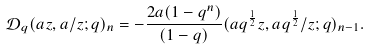Convert formula to latex. <formula><loc_0><loc_0><loc_500><loc_500>\mathcal { D } _ { q } ( a z , a / z ; q ) _ { n } = - \frac { 2 a ( 1 - q ^ { n } ) } { ( 1 - q ) } ( a q ^ { \frac { 1 } { 2 } } z , a q ^ { \frac { 1 } { 2 } } / z ; q ) _ { n - 1 } .</formula> 